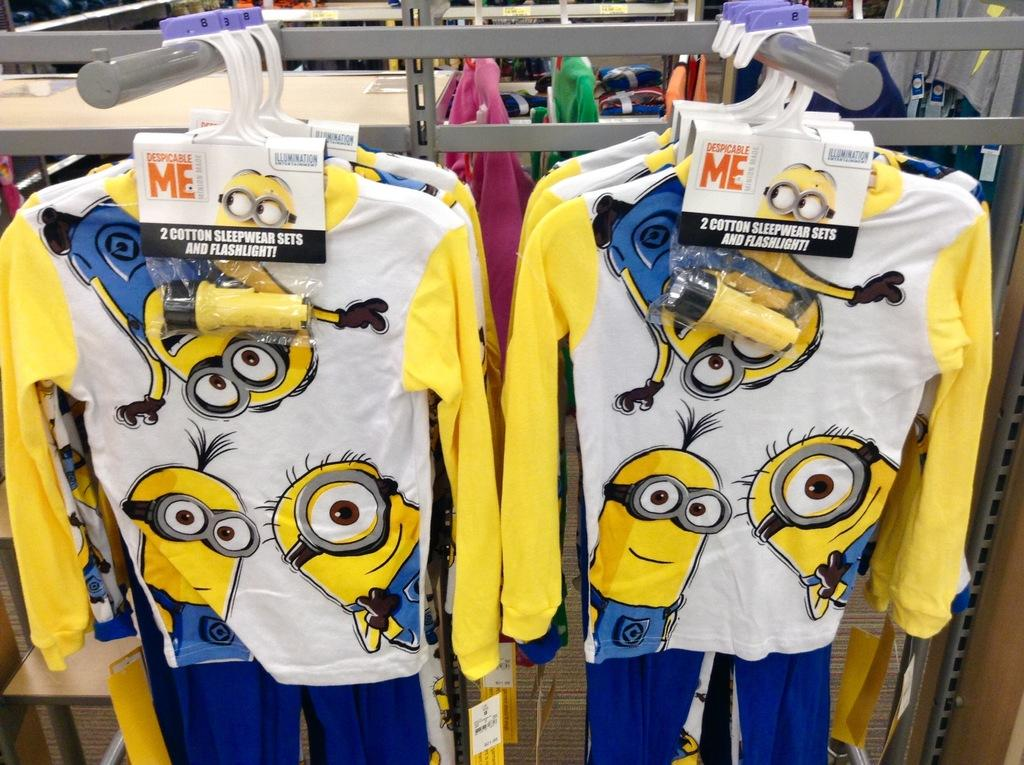Provide a one-sentence caption for the provided image. Pajamas from the movie Despicable Me come with a flashlight. 